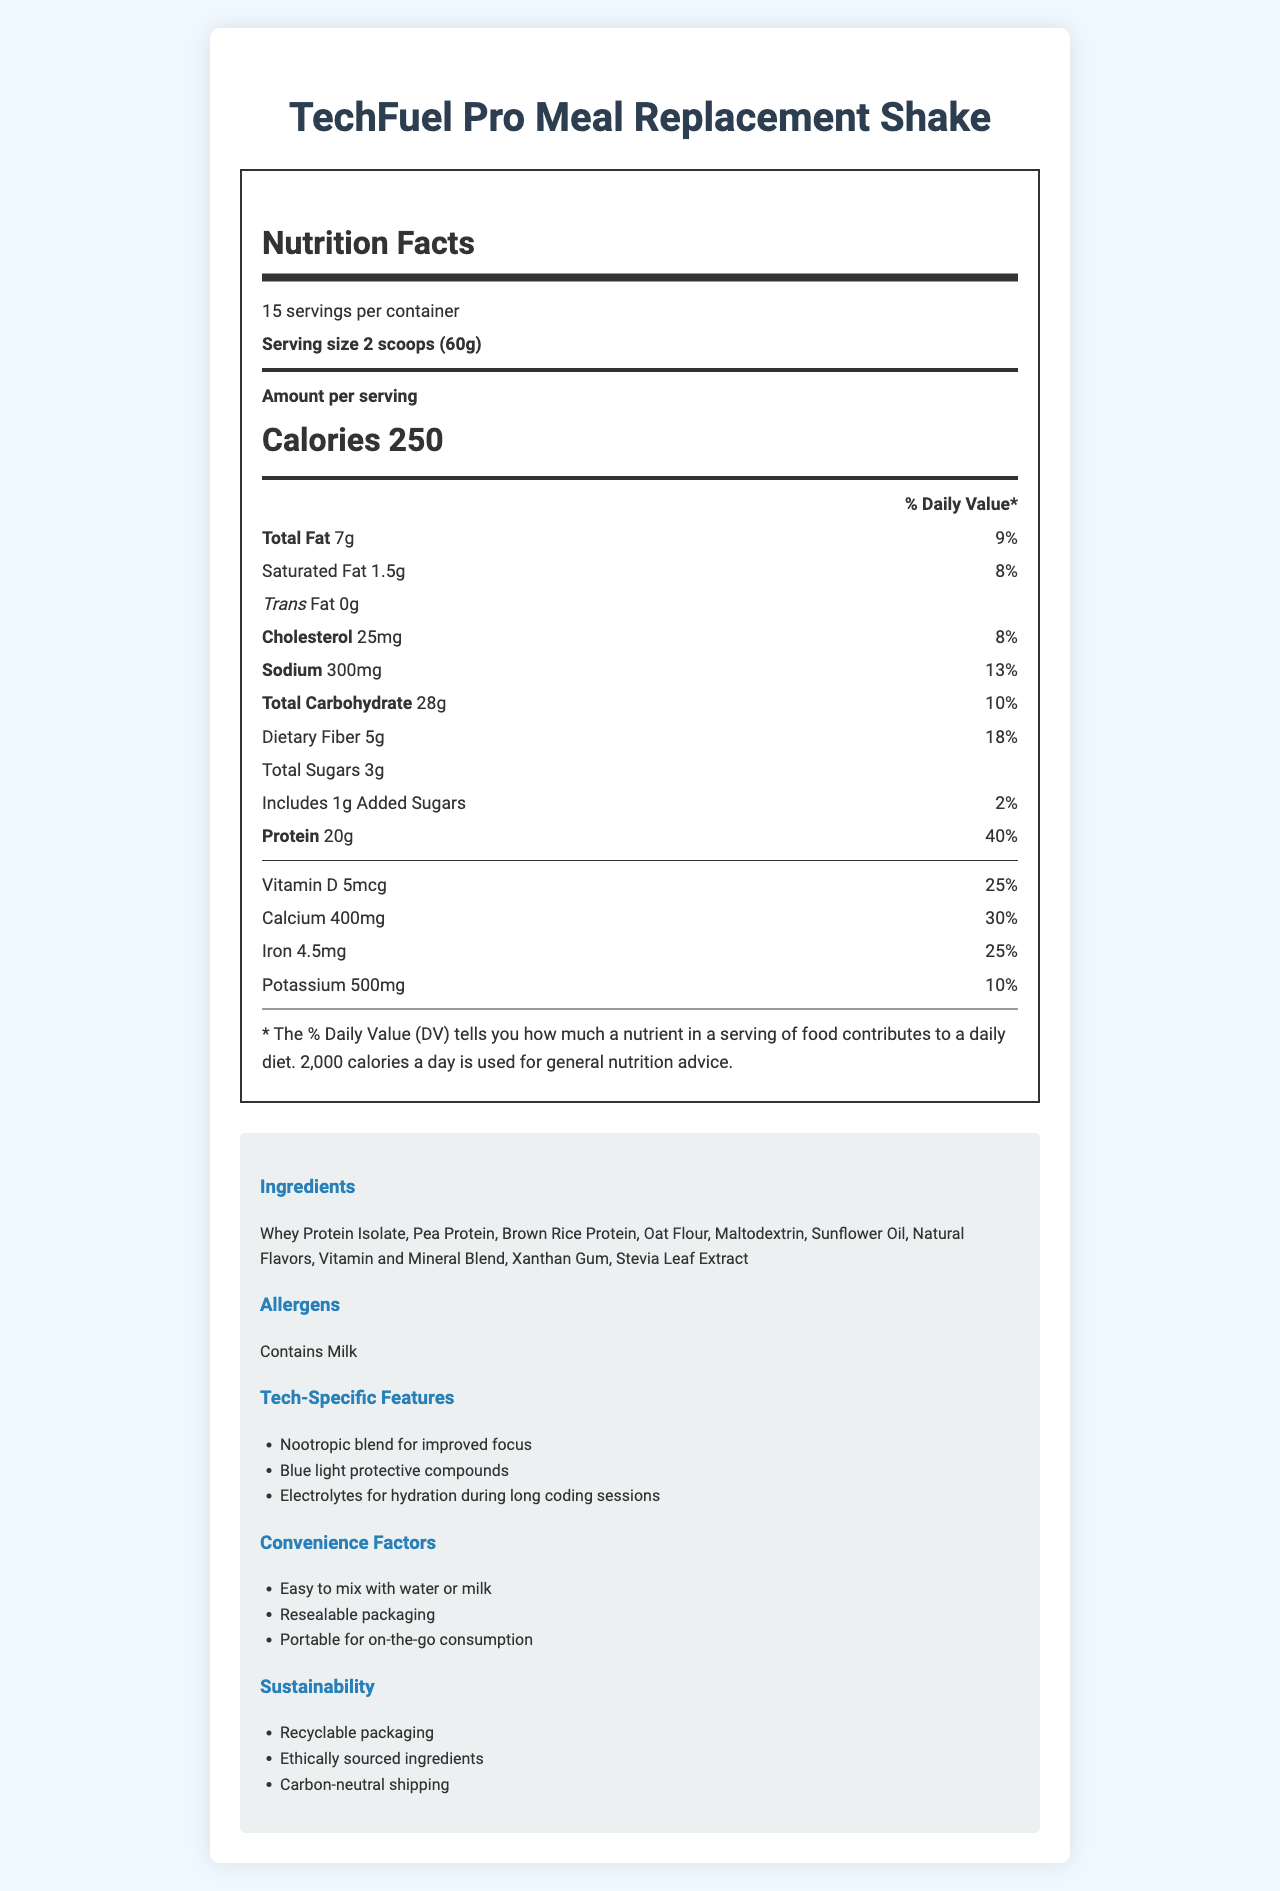what is the serving size of TechFuel Pro Meal Replacement Shake? The document states that the serving size is "2 scoops (60g)."
Answer: 2 scoops (60g) how many servings are in one container? The document specifies that there are 15 servings per container.
Answer: 15 how many calories are in one serving? The document lists the amount per serving as 250 calories.
Answer: 250 What is the total fat content in one serving? The document shows "Total Fat: 7g."
Answer: 7g What percentage of the daily value does the protein content represent? The document indicates that the protein content is 20g per serving, which represents 40% of the daily value.
Answer: 40% which vitamin has the highest % daily value per serving? A. Vitamin A B. Vitamin B6 C. Vitamin C D. Vitamin D The document lists Vitamin C as 45mg, contributing 50% of the daily value, which is the highest among the vitamins displayed.
Answer: C. Vitamin C How much sodium is in one serving of the meal replacement shake? The document states that one serving contains 300mg of sodium.
Answer: 300mg True or False: The shake contains added sugars. The document states that it contains "Includes 1g Added Sugars."
Answer: True What is one of the tech-specific features mentioned? The document lists several tech-specific features, including "Nootropic blend for improved focus."
Answer: Nootropic blend for improved focus what are the convenience factors listed for this meal replacement shake? The document mentions these three convenience factors.
Answer: Easy to mix with water or milk, Resealable packaging, Portable for on-the-go consumption What are the allergens contained in this product? The document indicates that the product "Contains Milk."
Answer: Milk Does this product contain any trans fat? The document lists "Trans Fat: 0g."
Answer: No what sustainability measures are taken by the brand? The document lists these sustainability measures under the "Sustainability" section.
Answer: Recyclable packaging, Ethically sourced ingredients, Carbon-neutral shipping Summarize the main idea of the document. The document details the nutritional content, ingredients, allergens, and special features of the TechFuel Pro Meal Replacement Shake, highlighting its convenience and sustainability.
Answer: TechFuel Pro Meal Replacement Shake provides essential nutrition for busy professionals, with convenient features, tech-specific benefits, and sustainable practices. what is the price of one container of the meal replacement shake? The document does not provide any information about the price of the product.
Answer: Cannot be determined 